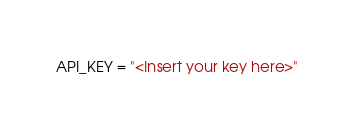Convert code to text. <code><loc_0><loc_0><loc_500><loc_500><_Python_>API_KEY = "<Insert your key here>"</code> 